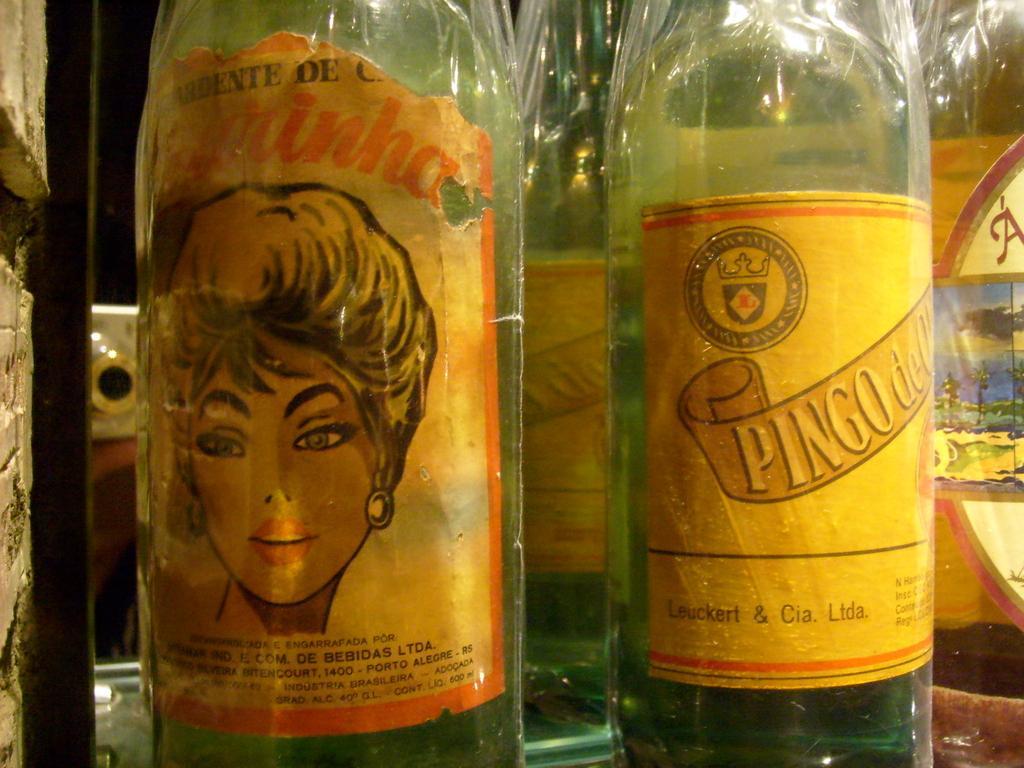Can you describe this image briefly? In this picture there are few bottles put on a table and beside that bottles there is a wall. 